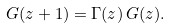Convert formula to latex. <formula><loc_0><loc_0><loc_500><loc_500>G ( z + 1 ) = \Gamma ( z ) \, G ( z ) .</formula> 